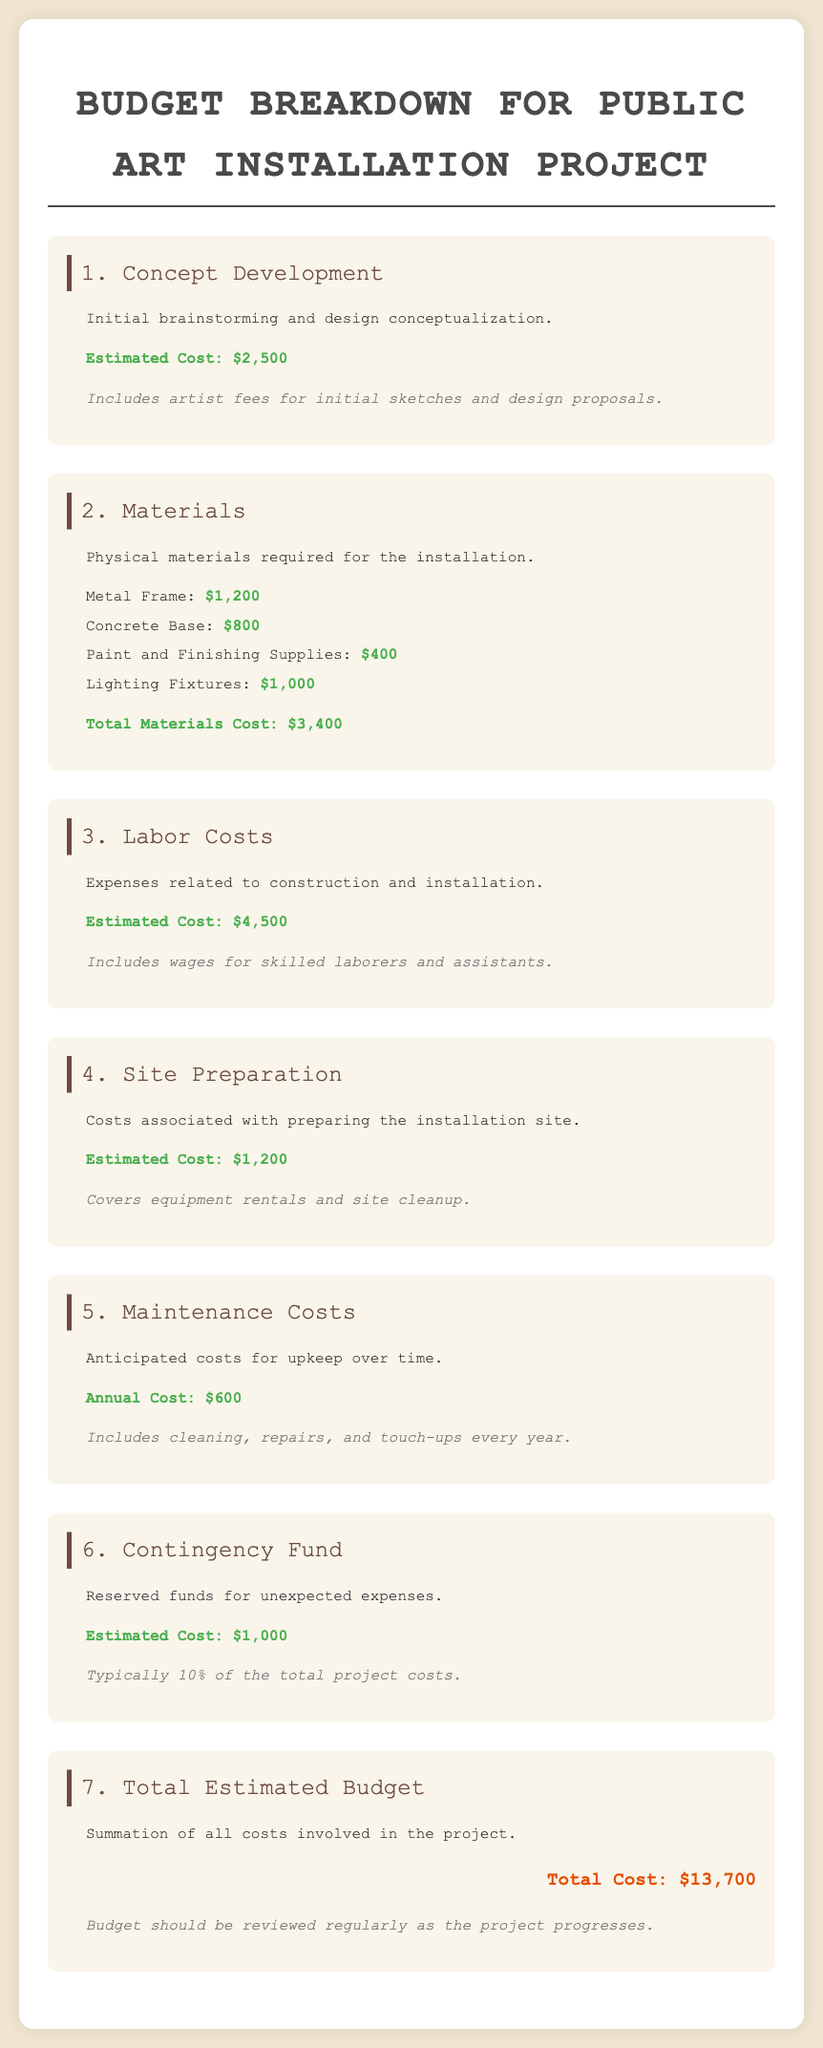What is the estimated cost for Concept Development? The estimated cost for Concept Development is specified in the document as $2,500.
Answer: $2,500 What is the total cost of Materials? The total cost of Materials is calculated from the individual material costs, which sum to $3,400.
Answer: $3,400 How much is allocated for Labor Costs? The document states the estimated cost for Labor Costs as $4,500.
Answer: $4,500 What is the cost for Site Preparation? The document provides the estimated cost for Site Preparation, which is $1,200.
Answer: $1,200 What is the annual Maintenance Cost? The anticipated annual Maintenance Cost mentioned in the document is $600.
Answer: $600 What percentage of the total project costs is the Contingency Fund estimated at? The Contingency Fund is noted to typically consist of 10% of the total project costs.
Answer: 10% What is the total estimated budget for the project? The total estimated budget for the project is summarized as $13,700 in the document.
Answer: $13,700 How much is included for cleaning and repairs in Maintenance Costs? The Maintenance Costs include cleaning and repairs for upkeep, quantified as $600 annually.
Answer: $600 